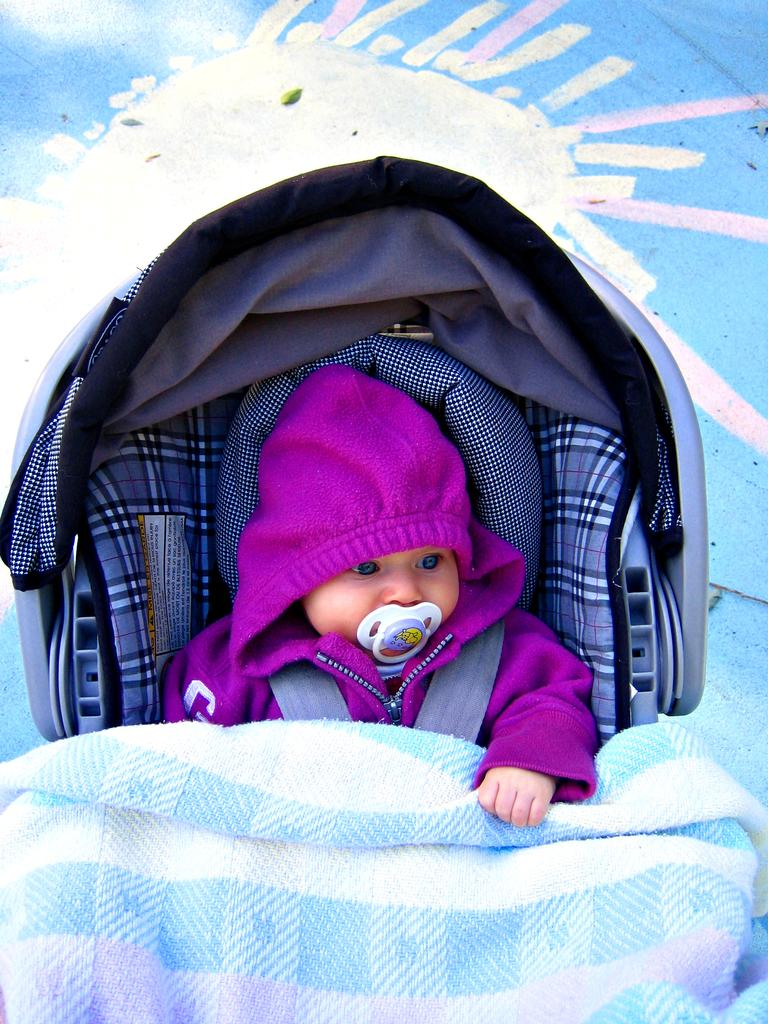What is in the trolley in the image? There is a baby in the trolley in the image. What is the baby wearing? The baby is wearing a coat. Who is the person with the baby in the image? There is a shipper in the image. What can be seen in the background of the image? There is a painting on the wall in the background. What material is visible in the image? There is a cloth visible in the image. Where is the meeting taking place in the image? There is no meeting present in the image; it features a baby in a trolley with a shipper and a painting in the background. 